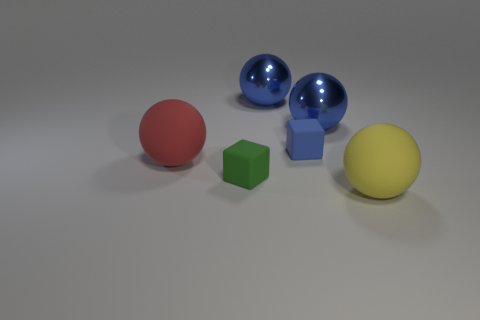Are the red sphere and the small green thing made of the same material?
Provide a short and direct response. Yes. How many small things are either blue cubes or blue rubber balls?
Provide a short and direct response. 1. The other block that is made of the same material as the blue cube is what color?
Offer a very short reply. Green. There is a cube that is in front of the red object; what color is it?
Your response must be concise. Green. Is the number of blue matte things in front of the large red object less than the number of large matte balls that are behind the yellow sphere?
Offer a terse response. Yes. What number of cubes are behind the big yellow rubber sphere?
Give a very brief answer. 2. Are there any cubes that have the same material as the big yellow object?
Give a very brief answer. Yes. Is the number of big balls behind the red matte thing greater than the number of big metallic objects that are in front of the blue cube?
Keep it short and to the point. Yes. The red matte sphere is what size?
Make the answer very short. Large. There is a small rubber object that is on the right side of the green rubber cube; what shape is it?
Your answer should be very brief. Cube. 